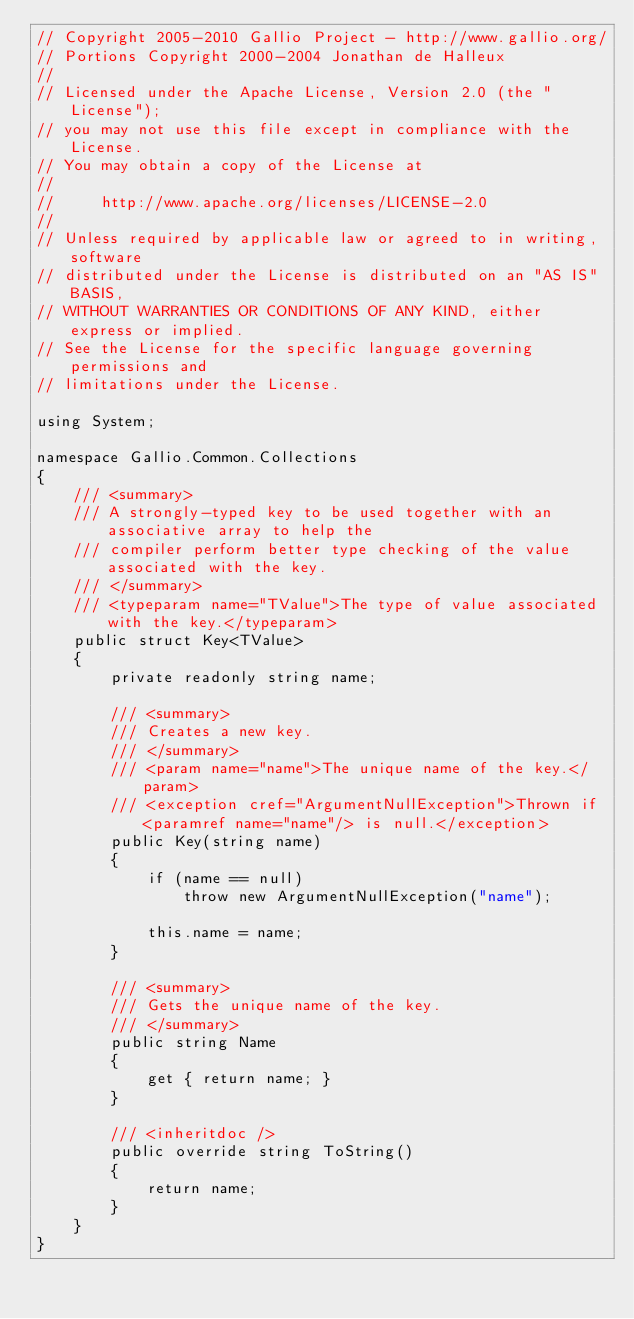<code> <loc_0><loc_0><loc_500><loc_500><_C#_>// Copyright 2005-2010 Gallio Project - http://www.gallio.org/
// Portions Copyright 2000-2004 Jonathan de Halleux
// 
// Licensed under the Apache License, Version 2.0 (the "License");
// you may not use this file except in compliance with the License.
// You may obtain a copy of the License at
// 
//     http://www.apache.org/licenses/LICENSE-2.0
// 
// Unless required by applicable law or agreed to in writing, software
// distributed under the License is distributed on an "AS IS" BASIS,
// WITHOUT WARRANTIES OR CONDITIONS OF ANY KIND, either express or implied.
// See the License for the specific language governing permissions and
// limitations under the License.

using System;

namespace Gallio.Common.Collections
{
    /// <summary>
    /// A strongly-typed key to be used together with an associative array to help the
    /// compiler perform better type checking of the value associated with the key.
    /// </summary>
    /// <typeparam name="TValue">The type of value associated with the key.</typeparam>
    public struct Key<TValue>
    {
        private readonly string name;

        /// <summary>
        /// Creates a new key.
        /// </summary>
        /// <param name="name">The unique name of the key.</param>
        /// <exception cref="ArgumentNullException">Thrown if <paramref name="name"/> is null.</exception>
        public Key(string name)
        {
            if (name == null)
                throw new ArgumentNullException("name");

            this.name = name;
        }

        /// <summary>
        /// Gets the unique name of the key.
        /// </summary>
        public string Name
        {
            get { return name; }
        }

        /// <inheritdoc />
        public override string ToString()
        {
            return name;
        }
    }
}
</code> 